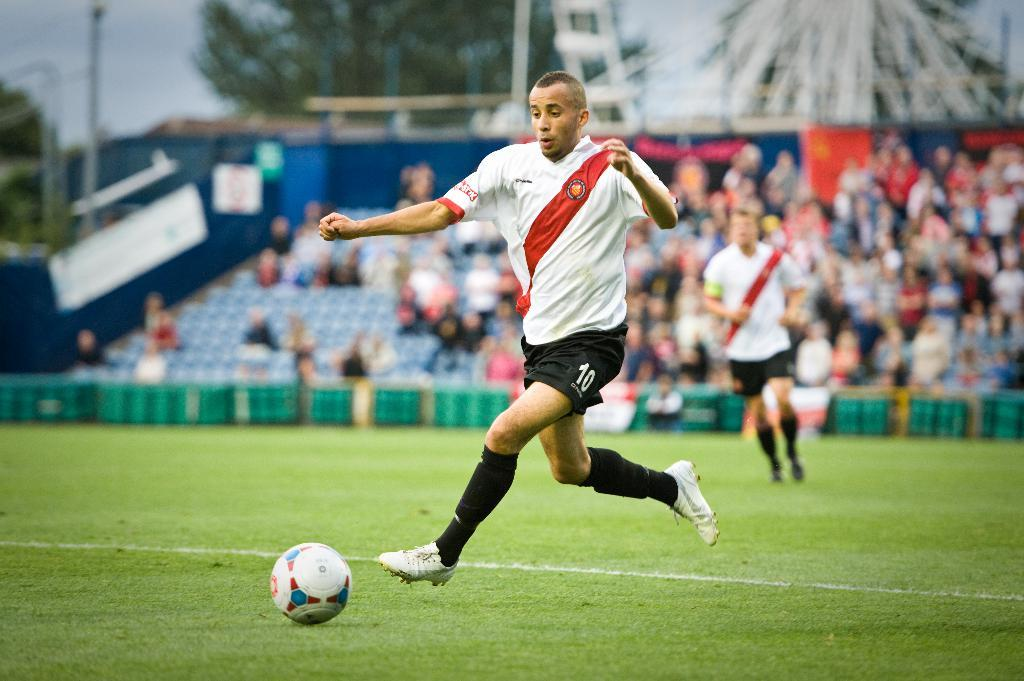Provide a one-sentence caption for the provided image. A man is about to kick a soccer ball and has the number 10 on his shorts. 